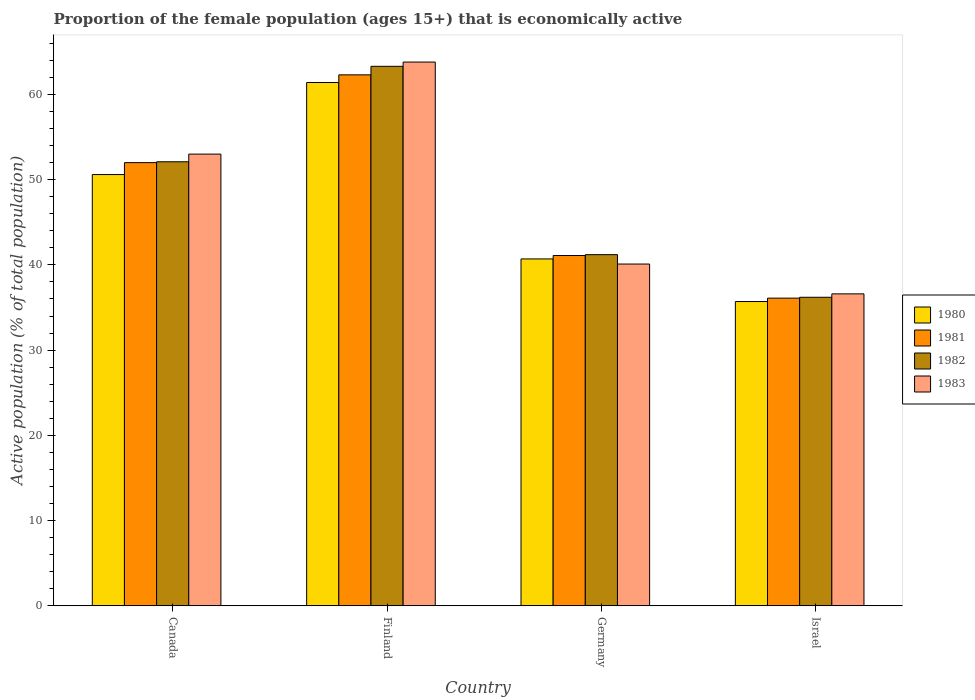How many different coloured bars are there?
Your answer should be compact. 4. Are the number of bars per tick equal to the number of legend labels?
Give a very brief answer. Yes. Are the number of bars on each tick of the X-axis equal?
Ensure brevity in your answer.  Yes. How many bars are there on the 1st tick from the left?
Your answer should be very brief. 4. In how many cases, is the number of bars for a given country not equal to the number of legend labels?
Your response must be concise. 0. What is the proportion of the female population that is economically active in 1980 in Canada?
Give a very brief answer. 50.6. Across all countries, what is the maximum proportion of the female population that is economically active in 1981?
Provide a short and direct response. 62.3. Across all countries, what is the minimum proportion of the female population that is economically active in 1981?
Ensure brevity in your answer.  36.1. In which country was the proportion of the female population that is economically active in 1982 maximum?
Provide a succinct answer. Finland. What is the total proportion of the female population that is economically active in 1983 in the graph?
Your answer should be compact. 193.5. What is the difference between the proportion of the female population that is economically active in 1982 in Finland and that in Germany?
Ensure brevity in your answer.  22.1. What is the difference between the proportion of the female population that is economically active in 1983 in Germany and the proportion of the female population that is economically active in 1981 in Finland?
Ensure brevity in your answer.  -22.2. What is the average proportion of the female population that is economically active in 1980 per country?
Give a very brief answer. 47.1. In how many countries, is the proportion of the female population that is economically active in 1983 greater than 22 %?
Provide a succinct answer. 4. What is the ratio of the proportion of the female population that is economically active in 1983 in Germany to that in Israel?
Your answer should be very brief. 1.1. Is the proportion of the female population that is economically active in 1983 in Finland less than that in Israel?
Give a very brief answer. No. What is the difference between the highest and the second highest proportion of the female population that is economically active in 1982?
Your answer should be compact. -10.9. What is the difference between the highest and the lowest proportion of the female population that is economically active in 1981?
Keep it short and to the point. 26.2. Is the sum of the proportion of the female population that is economically active in 1982 in Finland and Israel greater than the maximum proportion of the female population that is economically active in 1981 across all countries?
Offer a very short reply. Yes. What does the 4th bar from the right in Finland represents?
Offer a very short reply. 1980. Is it the case that in every country, the sum of the proportion of the female population that is economically active in 1980 and proportion of the female population that is economically active in 1981 is greater than the proportion of the female population that is economically active in 1983?
Give a very brief answer. Yes. What is the difference between two consecutive major ticks on the Y-axis?
Provide a short and direct response. 10. Where does the legend appear in the graph?
Offer a very short reply. Center right. How many legend labels are there?
Your answer should be compact. 4. What is the title of the graph?
Your answer should be compact. Proportion of the female population (ages 15+) that is economically active. What is the label or title of the Y-axis?
Your answer should be very brief. Active population (% of total population). What is the Active population (% of total population) of 1980 in Canada?
Make the answer very short. 50.6. What is the Active population (% of total population) in 1981 in Canada?
Give a very brief answer. 52. What is the Active population (% of total population) in 1982 in Canada?
Your response must be concise. 52.1. What is the Active population (% of total population) in 1980 in Finland?
Keep it short and to the point. 61.4. What is the Active population (% of total population) in 1981 in Finland?
Give a very brief answer. 62.3. What is the Active population (% of total population) of 1982 in Finland?
Your response must be concise. 63.3. What is the Active population (% of total population) in 1983 in Finland?
Give a very brief answer. 63.8. What is the Active population (% of total population) in 1980 in Germany?
Your answer should be very brief. 40.7. What is the Active population (% of total population) in 1981 in Germany?
Offer a very short reply. 41.1. What is the Active population (% of total population) of 1982 in Germany?
Your answer should be very brief. 41.2. What is the Active population (% of total population) in 1983 in Germany?
Offer a very short reply. 40.1. What is the Active population (% of total population) of 1980 in Israel?
Keep it short and to the point. 35.7. What is the Active population (% of total population) of 1981 in Israel?
Your answer should be very brief. 36.1. What is the Active population (% of total population) of 1982 in Israel?
Offer a terse response. 36.2. What is the Active population (% of total population) in 1983 in Israel?
Provide a succinct answer. 36.6. Across all countries, what is the maximum Active population (% of total population) of 1980?
Ensure brevity in your answer.  61.4. Across all countries, what is the maximum Active population (% of total population) in 1981?
Your answer should be compact. 62.3. Across all countries, what is the maximum Active population (% of total population) in 1982?
Offer a terse response. 63.3. Across all countries, what is the maximum Active population (% of total population) in 1983?
Offer a terse response. 63.8. Across all countries, what is the minimum Active population (% of total population) of 1980?
Keep it short and to the point. 35.7. Across all countries, what is the minimum Active population (% of total population) in 1981?
Provide a short and direct response. 36.1. Across all countries, what is the minimum Active population (% of total population) of 1982?
Make the answer very short. 36.2. Across all countries, what is the minimum Active population (% of total population) of 1983?
Provide a short and direct response. 36.6. What is the total Active population (% of total population) in 1980 in the graph?
Offer a very short reply. 188.4. What is the total Active population (% of total population) in 1981 in the graph?
Your response must be concise. 191.5. What is the total Active population (% of total population) in 1982 in the graph?
Your answer should be compact. 192.8. What is the total Active population (% of total population) of 1983 in the graph?
Your answer should be very brief. 193.5. What is the difference between the Active population (% of total population) in 1980 in Canada and that in Finland?
Offer a terse response. -10.8. What is the difference between the Active population (% of total population) in 1981 in Canada and that in Finland?
Make the answer very short. -10.3. What is the difference between the Active population (% of total population) of 1982 in Canada and that in Germany?
Ensure brevity in your answer.  10.9. What is the difference between the Active population (% of total population) of 1983 in Canada and that in Germany?
Provide a short and direct response. 12.9. What is the difference between the Active population (% of total population) of 1981 in Canada and that in Israel?
Provide a succinct answer. 15.9. What is the difference between the Active population (% of total population) of 1983 in Canada and that in Israel?
Your answer should be very brief. 16.4. What is the difference between the Active population (% of total population) in 1980 in Finland and that in Germany?
Give a very brief answer. 20.7. What is the difference between the Active population (% of total population) in 1981 in Finland and that in Germany?
Your response must be concise. 21.2. What is the difference between the Active population (% of total population) in 1982 in Finland and that in Germany?
Your answer should be very brief. 22.1. What is the difference between the Active population (% of total population) in 1983 in Finland and that in Germany?
Ensure brevity in your answer.  23.7. What is the difference between the Active population (% of total population) of 1980 in Finland and that in Israel?
Offer a terse response. 25.7. What is the difference between the Active population (% of total population) in 1981 in Finland and that in Israel?
Provide a short and direct response. 26.2. What is the difference between the Active population (% of total population) of 1982 in Finland and that in Israel?
Your answer should be very brief. 27.1. What is the difference between the Active population (% of total population) in 1983 in Finland and that in Israel?
Provide a short and direct response. 27.2. What is the difference between the Active population (% of total population) of 1980 in Germany and that in Israel?
Make the answer very short. 5. What is the difference between the Active population (% of total population) in 1983 in Germany and that in Israel?
Your answer should be very brief. 3.5. What is the difference between the Active population (% of total population) of 1980 in Canada and the Active population (% of total population) of 1981 in Finland?
Offer a terse response. -11.7. What is the difference between the Active population (% of total population) in 1980 in Canada and the Active population (% of total population) in 1982 in Finland?
Provide a succinct answer. -12.7. What is the difference between the Active population (% of total population) of 1982 in Canada and the Active population (% of total population) of 1983 in Finland?
Ensure brevity in your answer.  -11.7. What is the difference between the Active population (% of total population) of 1982 in Canada and the Active population (% of total population) of 1983 in Germany?
Offer a terse response. 12. What is the difference between the Active population (% of total population) of 1982 in Canada and the Active population (% of total population) of 1983 in Israel?
Offer a terse response. 15.5. What is the difference between the Active population (% of total population) in 1980 in Finland and the Active population (% of total population) in 1981 in Germany?
Make the answer very short. 20.3. What is the difference between the Active population (% of total population) in 1980 in Finland and the Active population (% of total population) in 1982 in Germany?
Offer a terse response. 20.2. What is the difference between the Active population (% of total population) in 1980 in Finland and the Active population (% of total population) in 1983 in Germany?
Provide a short and direct response. 21.3. What is the difference between the Active population (% of total population) of 1981 in Finland and the Active population (% of total population) of 1982 in Germany?
Your response must be concise. 21.1. What is the difference between the Active population (% of total population) in 1981 in Finland and the Active population (% of total population) in 1983 in Germany?
Keep it short and to the point. 22.2. What is the difference between the Active population (% of total population) of 1982 in Finland and the Active population (% of total population) of 1983 in Germany?
Your response must be concise. 23.2. What is the difference between the Active population (% of total population) of 1980 in Finland and the Active population (% of total population) of 1981 in Israel?
Provide a succinct answer. 25.3. What is the difference between the Active population (% of total population) of 1980 in Finland and the Active population (% of total population) of 1982 in Israel?
Make the answer very short. 25.2. What is the difference between the Active population (% of total population) of 1980 in Finland and the Active population (% of total population) of 1983 in Israel?
Your response must be concise. 24.8. What is the difference between the Active population (% of total population) of 1981 in Finland and the Active population (% of total population) of 1982 in Israel?
Your answer should be very brief. 26.1. What is the difference between the Active population (% of total population) in 1981 in Finland and the Active population (% of total population) in 1983 in Israel?
Provide a short and direct response. 25.7. What is the difference between the Active population (% of total population) of 1982 in Finland and the Active population (% of total population) of 1983 in Israel?
Provide a succinct answer. 26.7. What is the difference between the Active population (% of total population) in 1980 in Germany and the Active population (% of total population) in 1982 in Israel?
Your response must be concise. 4.5. What is the difference between the Active population (% of total population) in 1981 in Germany and the Active population (% of total population) in 1982 in Israel?
Provide a succinct answer. 4.9. What is the difference between the Active population (% of total population) of 1981 in Germany and the Active population (% of total population) of 1983 in Israel?
Your answer should be very brief. 4.5. What is the difference between the Active population (% of total population) in 1982 in Germany and the Active population (% of total population) in 1983 in Israel?
Offer a terse response. 4.6. What is the average Active population (% of total population) of 1980 per country?
Provide a succinct answer. 47.1. What is the average Active population (% of total population) of 1981 per country?
Offer a very short reply. 47.88. What is the average Active population (% of total population) of 1982 per country?
Offer a terse response. 48.2. What is the average Active population (% of total population) of 1983 per country?
Provide a short and direct response. 48.38. What is the difference between the Active population (% of total population) in 1980 and Active population (% of total population) in 1981 in Canada?
Provide a succinct answer. -1.4. What is the difference between the Active population (% of total population) in 1980 and Active population (% of total population) in 1982 in Canada?
Your answer should be very brief. -1.5. What is the difference between the Active population (% of total population) of 1980 and Active population (% of total population) of 1983 in Canada?
Offer a very short reply. -2.4. What is the difference between the Active population (% of total population) in 1981 and Active population (% of total population) in 1983 in Canada?
Provide a succinct answer. -1. What is the difference between the Active population (% of total population) of 1980 and Active population (% of total population) of 1982 in Finland?
Offer a very short reply. -1.9. What is the difference between the Active population (% of total population) in 1980 and Active population (% of total population) in 1983 in Finland?
Keep it short and to the point. -2.4. What is the difference between the Active population (% of total population) of 1981 and Active population (% of total population) of 1982 in Finland?
Offer a terse response. -1. What is the difference between the Active population (% of total population) of 1980 and Active population (% of total population) of 1982 in Germany?
Your answer should be very brief. -0.5. What is the difference between the Active population (% of total population) of 1980 and Active population (% of total population) of 1983 in Germany?
Give a very brief answer. 0.6. What is the difference between the Active population (% of total population) in 1981 and Active population (% of total population) in 1983 in Germany?
Provide a succinct answer. 1. What is the difference between the Active population (% of total population) in 1982 and Active population (% of total population) in 1983 in Germany?
Offer a very short reply. 1.1. What is the ratio of the Active population (% of total population) of 1980 in Canada to that in Finland?
Make the answer very short. 0.82. What is the ratio of the Active population (% of total population) of 1981 in Canada to that in Finland?
Keep it short and to the point. 0.83. What is the ratio of the Active population (% of total population) of 1982 in Canada to that in Finland?
Offer a very short reply. 0.82. What is the ratio of the Active population (% of total population) of 1983 in Canada to that in Finland?
Offer a terse response. 0.83. What is the ratio of the Active population (% of total population) of 1980 in Canada to that in Germany?
Provide a succinct answer. 1.24. What is the ratio of the Active population (% of total population) in 1981 in Canada to that in Germany?
Make the answer very short. 1.27. What is the ratio of the Active population (% of total population) of 1982 in Canada to that in Germany?
Give a very brief answer. 1.26. What is the ratio of the Active population (% of total population) in 1983 in Canada to that in Germany?
Make the answer very short. 1.32. What is the ratio of the Active population (% of total population) in 1980 in Canada to that in Israel?
Give a very brief answer. 1.42. What is the ratio of the Active population (% of total population) in 1981 in Canada to that in Israel?
Keep it short and to the point. 1.44. What is the ratio of the Active population (% of total population) in 1982 in Canada to that in Israel?
Make the answer very short. 1.44. What is the ratio of the Active population (% of total population) in 1983 in Canada to that in Israel?
Your response must be concise. 1.45. What is the ratio of the Active population (% of total population) in 1980 in Finland to that in Germany?
Provide a succinct answer. 1.51. What is the ratio of the Active population (% of total population) in 1981 in Finland to that in Germany?
Keep it short and to the point. 1.52. What is the ratio of the Active population (% of total population) in 1982 in Finland to that in Germany?
Give a very brief answer. 1.54. What is the ratio of the Active population (% of total population) in 1983 in Finland to that in Germany?
Ensure brevity in your answer.  1.59. What is the ratio of the Active population (% of total population) of 1980 in Finland to that in Israel?
Make the answer very short. 1.72. What is the ratio of the Active population (% of total population) of 1981 in Finland to that in Israel?
Offer a terse response. 1.73. What is the ratio of the Active population (% of total population) of 1982 in Finland to that in Israel?
Your response must be concise. 1.75. What is the ratio of the Active population (% of total population) in 1983 in Finland to that in Israel?
Offer a terse response. 1.74. What is the ratio of the Active population (% of total population) in 1980 in Germany to that in Israel?
Your answer should be compact. 1.14. What is the ratio of the Active population (% of total population) in 1981 in Germany to that in Israel?
Your answer should be very brief. 1.14. What is the ratio of the Active population (% of total population) of 1982 in Germany to that in Israel?
Your response must be concise. 1.14. What is the ratio of the Active population (% of total population) in 1983 in Germany to that in Israel?
Offer a terse response. 1.1. What is the difference between the highest and the second highest Active population (% of total population) in 1980?
Give a very brief answer. 10.8. What is the difference between the highest and the second highest Active population (% of total population) in 1982?
Your answer should be compact. 11.2. What is the difference between the highest and the lowest Active population (% of total population) of 1980?
Provide a succinct answer. 25.7. What is the difference between the highest and the lowest Active population (% of total population) of 1981?
Your response must be concise. 26.2. What is the difference between the highest and the lowest Active population (% of total population) of 1982?
Keep it short and to the point. 27.1. What is the difference between the highest and the lowest Active population (% of total population) of 1983?
Your response must be concise. 27.2. 